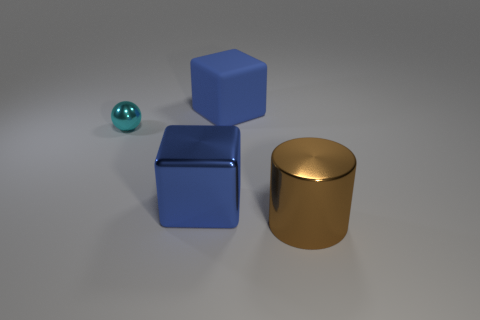Is the size of the cylinder the same as the shiny thing to the left of the metal cube?
Provide a succinct answer. No. There is a blue object behind the sphere; is there a matte cube on the right side of it?
Offer a terse response. No. There is a object that is in front of the cyan sphere and left of the rubber thing; what is its material?
Your answer should be very brief. Metal. What is the color of the big object that is to the left of the large object that is behind the large shiny object to the left of the metallic cylinder?
Keep it short and to the point. Blue. What color is the shiny block that is the same size as the metal cylinder?
Your answer should be compact. Blue. Does the matte object have the same color as the block that is in front of the small ball?
Ensure brevity in your answer.  Yes. What is the large blue block behind the large cube on the left side of the big matte thing made of?
Ensure brevity in your answer.  Rubber. What number of objects are behind the metallic block and right of the tiny metal thing?
Your response must be concise. 1. What number of other things are the same size as the sphere?
Your answer should be compact. 0. Does the object behind the small thing have the same shape as the blue object that is in front of the small cyan ball?
Your answer should be compact. Yes. 